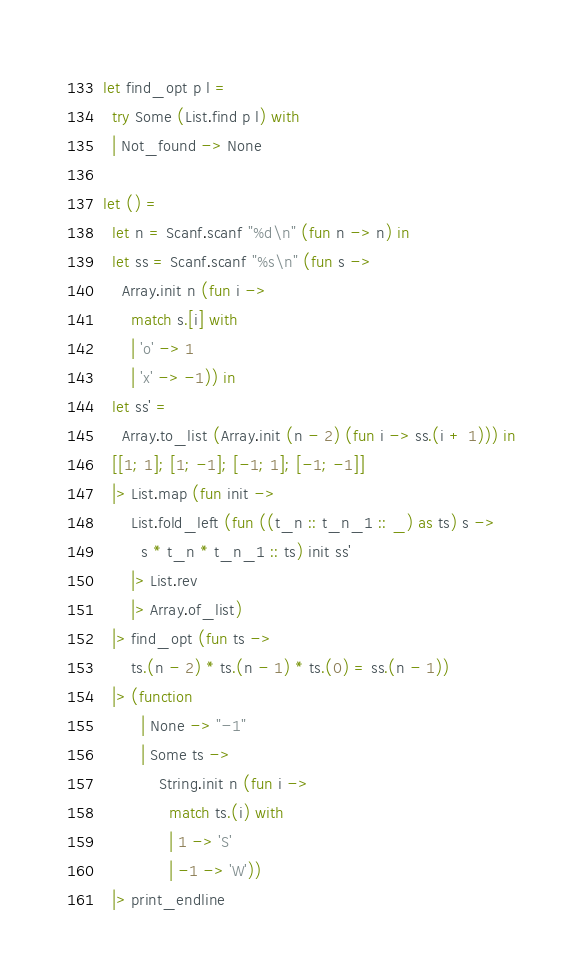Convert code to text. <code><loc_0><loc_0><loc_500><loc_500><_OCaml_>let find_opt p l =
  try Some (List.find p l) with
  | Not_found -> None

let () =
  let n = Scanf.scanf "%d\n" (fun n -> n) in
  let ss = Scanf.scanf "%s\n" (fun s ->
    Array.init n (fun i ->
      match s.[i] with
      | 'o' -> 1
      | 'x' -> -1)) in
  let ss' =
    Array.to_list (Array.init (n - 2) (fun i -> ss.(i + 1))) in
  [[1; 1]; [1; -1]; [-1; 1]; [-1; -1]]
  |> List.map (fun init ->
      List.fold_left (fun ((t_n :: t_n_1 :: _) as ts) s ->
        s * t_n * t_n_1 :: ts) init ss'
      |> List.rev
      |> Array.of_list)
  |> find_opt (fun ts ->
      ts.(n - 2) * ts.(n - 1) * ts.(0) = ss.(n - 1))
  |> (function
        | None -> "-1"
        | Some ts ->
            String.init n (fun i ->
              match ts.(i) with
              | 1 -> 'S'
              | -1 -> 'W'))
  |> print_endline
</code> 